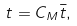Convert formula to latex. <formula><loc_0><loc_0><loc_500><loc_500>t = { C _ { M } } { \bar { t } } ,</formula> 